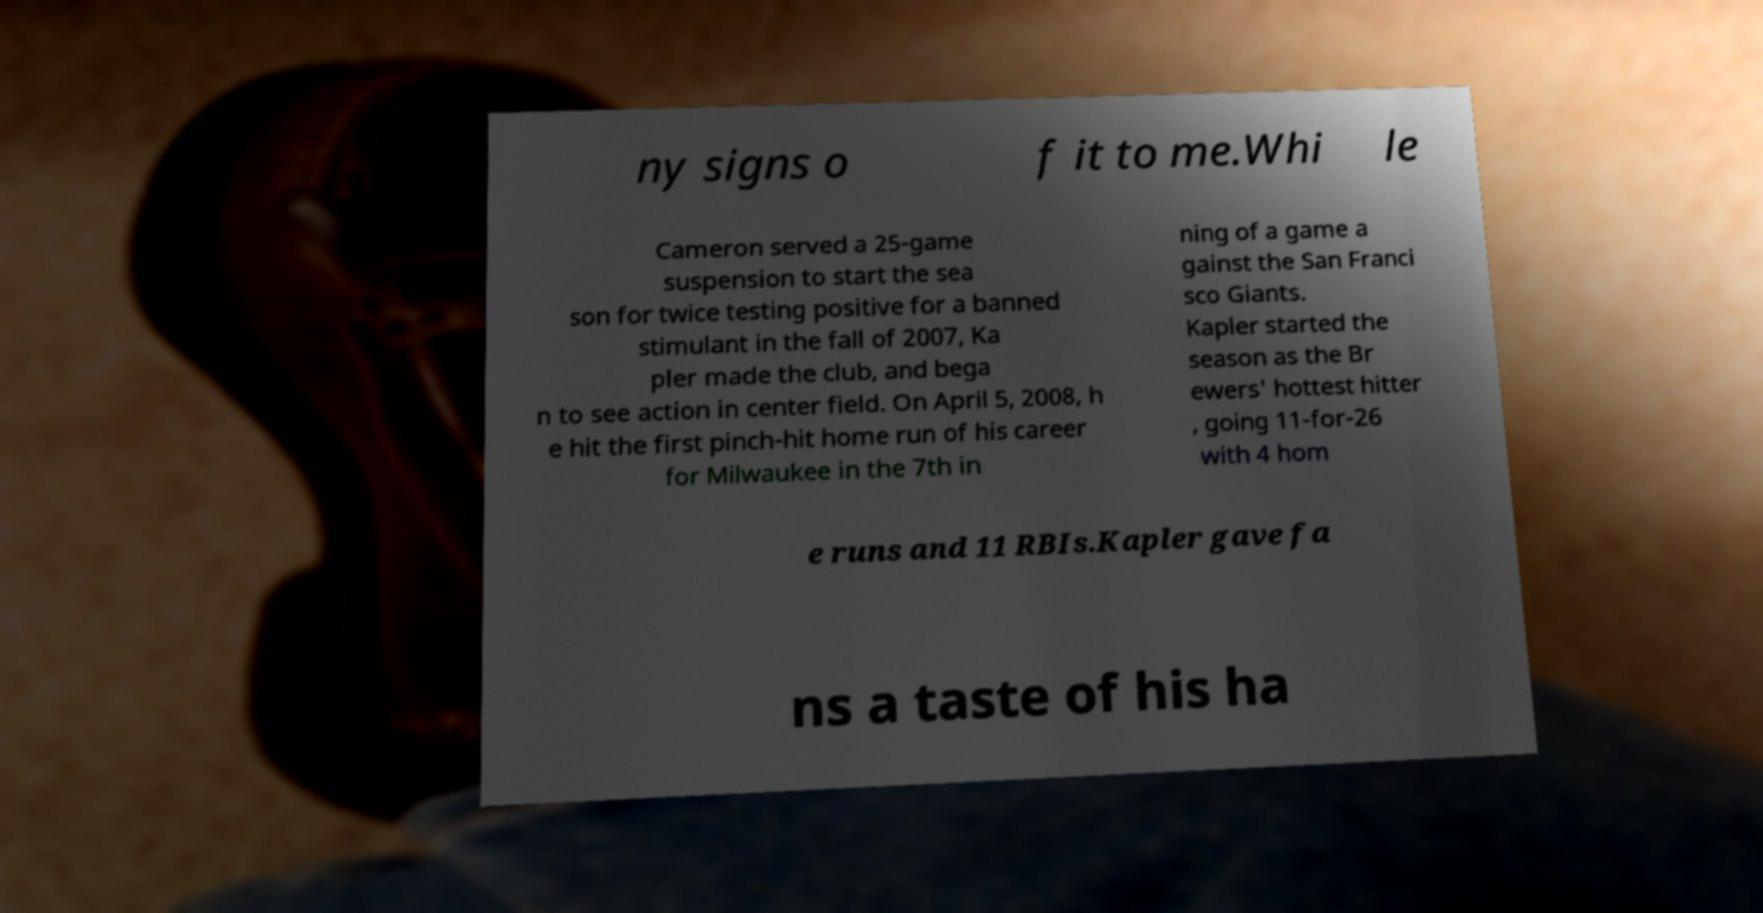There's text embedded in this image that I need extracted. Can you transcribe it verbatim? ny signs o f it to me.Whi le Cameron served a 25-game suspension to start the sea son for twice testing positive for a banned stimulant in the fall of 2007, Ka pler made the club, and bega n to see action in center field. On April 5, 2008, h e hit the first pinch-hit home run of his career for Milwaukee in the 7th in ning of a game a gainst the San Franci sco Giants. Kapler started the season as the Br ewers' hottest hitter , going 11-for-26 with 4 hom e runs and 11 RBIs.Kapler gave fa ns a taste of his ha 